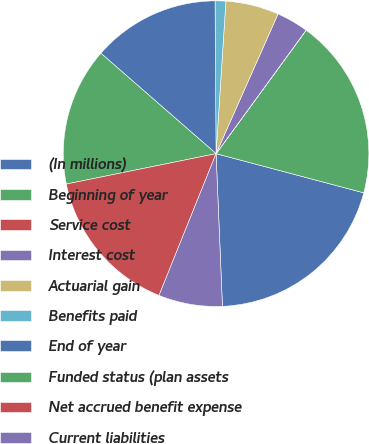<chart> <loc_0><loc_0><loc_500><loc_500><pie_chart><fcel>(In millions)<fcel>Beginning of year<fcel>Service cost<fcel>Interest cost<fcel>Actuarial gain<fcel>Benefits paid<fcel>End of year<fcel>Funded status (plan assets<fcel>Net accrued benefit expense<fcel>Current liabilities<nl><fcel>20.21%<fcel>19.09%<fcel>0.01%<fcel>3.38%<fcel>5.62%<fcel>1.13%<fcel>13.48%<fcel>14.6%<fcel>15.72%<fcel>6.75%<nl></chart> 